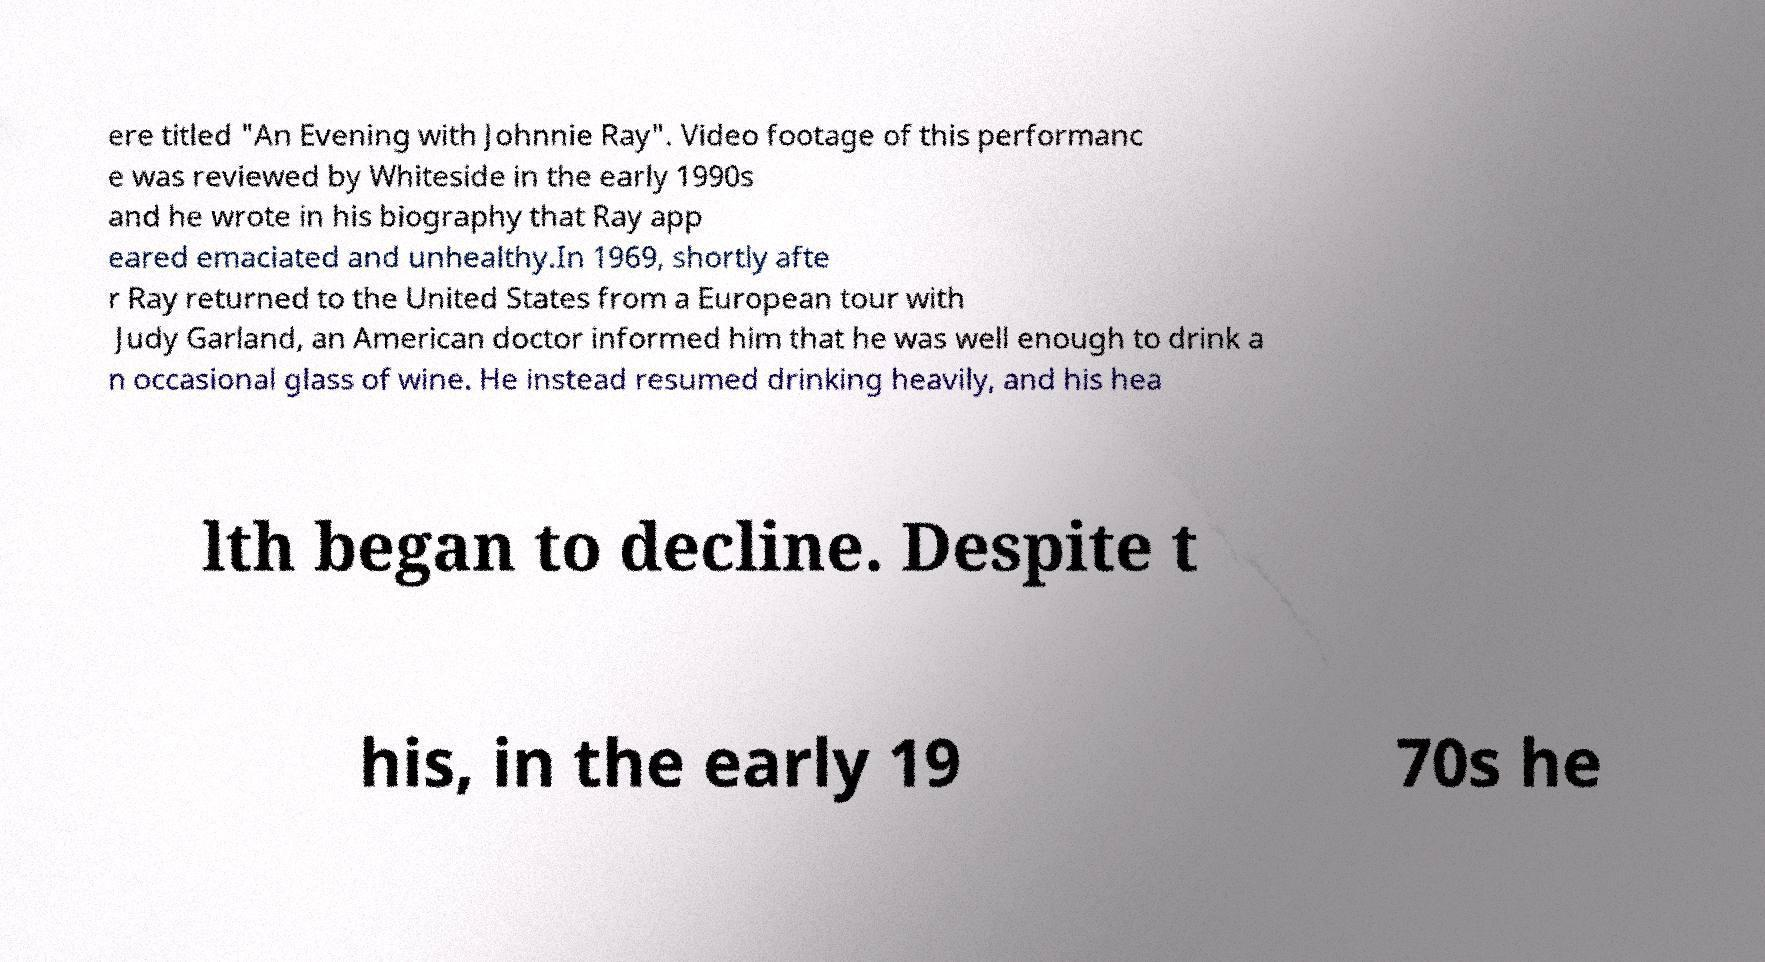Can you accurately transcribe the text from the provided image for me? ere titled "An Evening with Johnnie Ray". Video footage of this performanc e was reviewed by Whiteside in the early 1990s and he wrote in his biography that Ray app eared emaciated and unhealthy.In 1969, shortly afte r Ray returned to the United States from a European tour with Judy Garland, an American doctor informed him that he was well enough to drink a n occasional glass of wine. He instead resumed drinking heavily, and his hea lth began to decline. Despite t his, in the early 19 70s he 